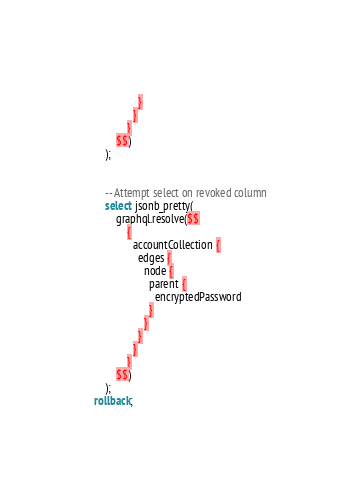Convert code to text. <code><loc_0><loc_0><loc_500><loc_500><_SQL_>                }
              }
            }
        $$)
    );


    -- Attempt select on revoked column
    select jsonb_pretty(
        graphql.resolve($$
            {
              accountCollection {
                edges {
                  node {
                    parent {
                      encryptedPassword
                    }
                  }
                }
              }
            }
        $$)
    );
rollback;
</code> 